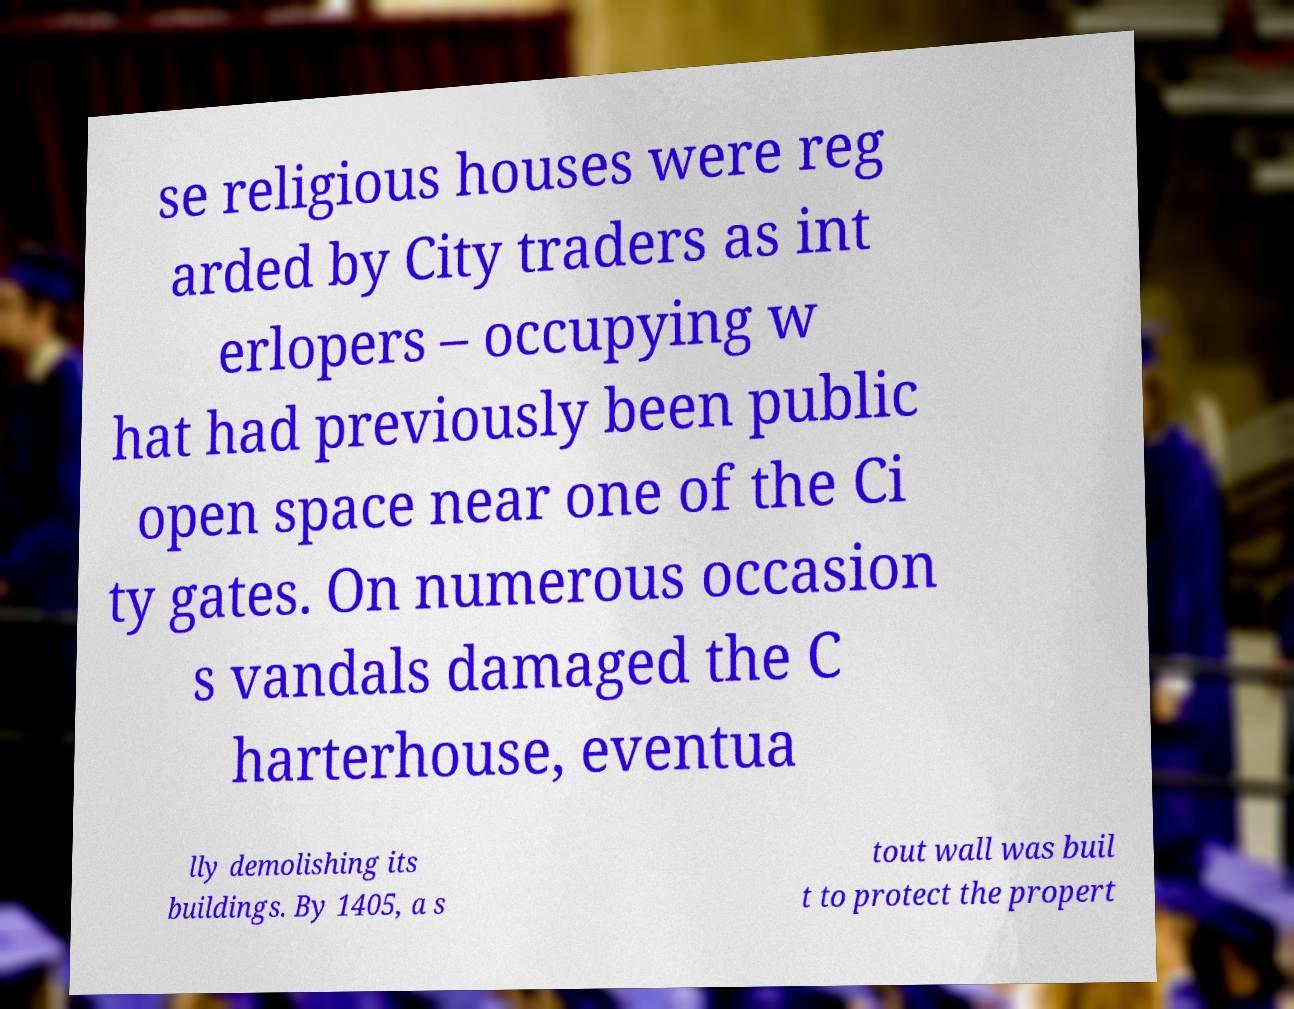What messages or text are displayed in this image? I need them in a readable, typed format. se religious houses were reg arded by City traders as int erlopers – occupying w hat had previously been public open space near one of the Ci ty gates. On numerous occasion s vandals damaged the C harterhouse, eventua lly demolishing its buildings. By 1405, a s tout wall was buil t to protect the propert 